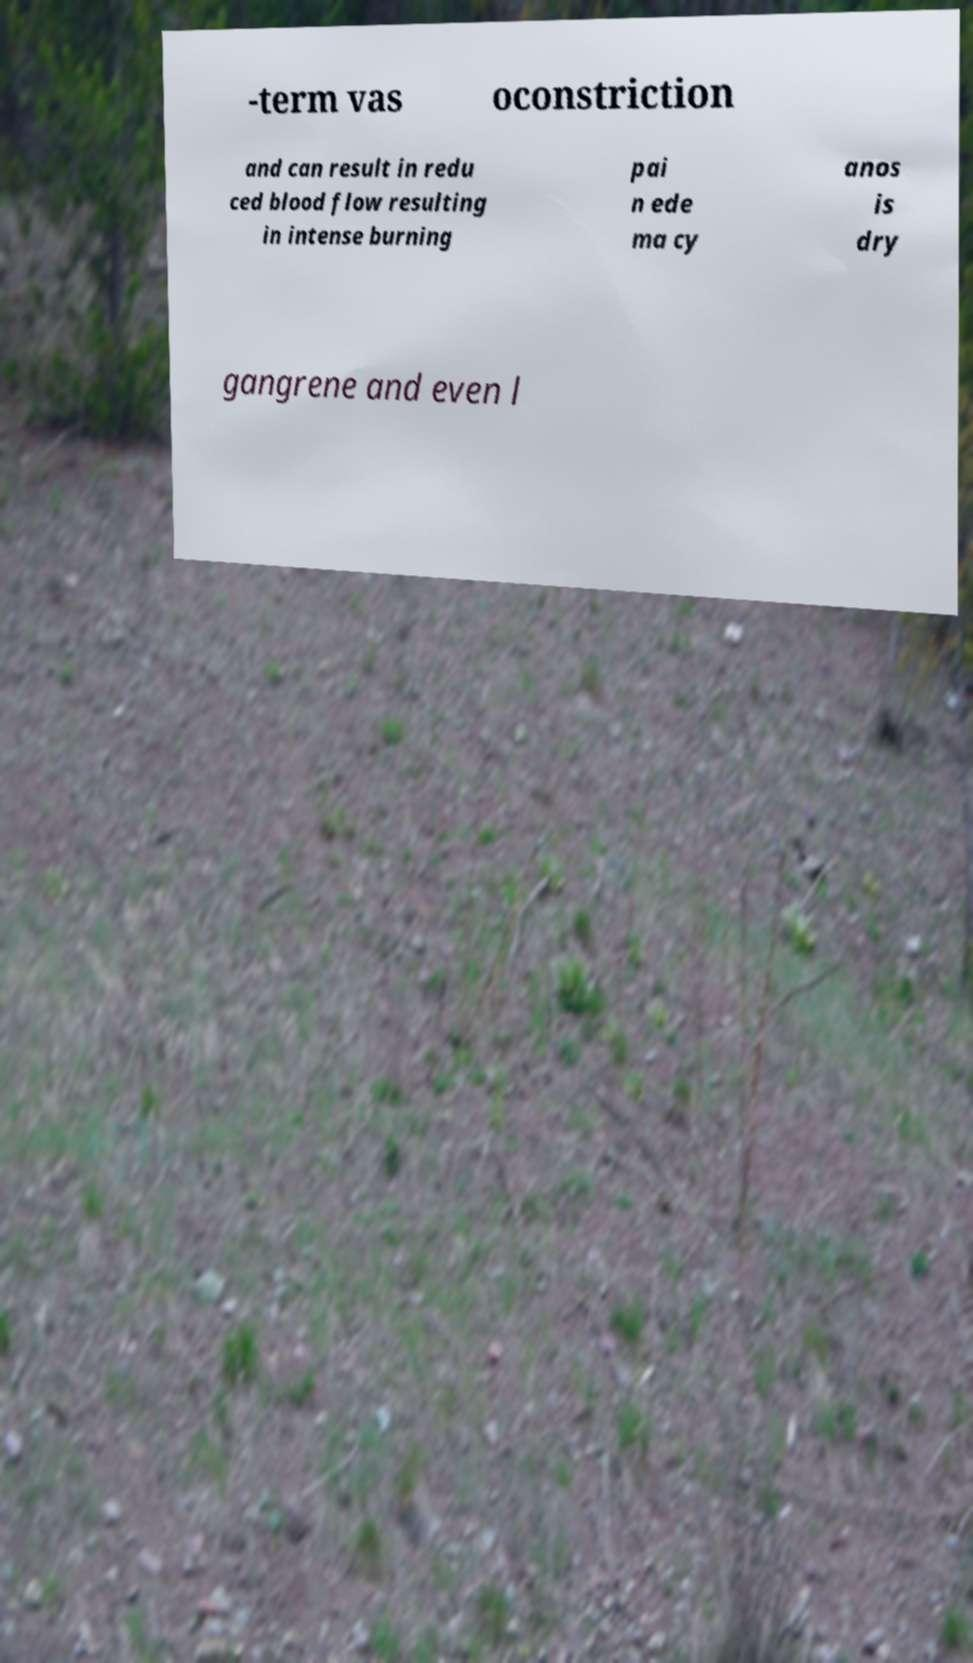Please identify and transcribe the text found in this image. -term vas oconstriction and can result in redu ced blood flow resulting in intense burning pai n ede ma cy anos is dry gangrene and even l 